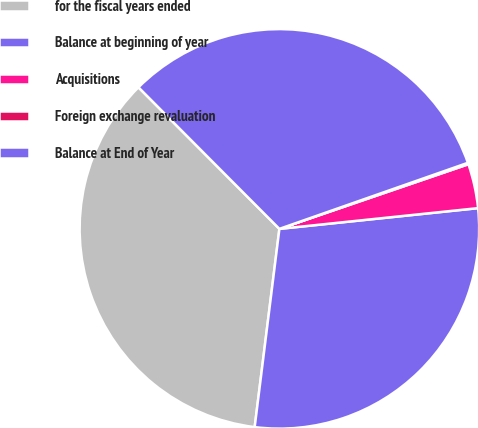<chart> <loc_0><loc_0><loc_500><loc_500><pie_chart><fcel>for the fiscal years ended<fcel>Balance at beginning of year<fcel>Acquisitions<fcel>Foreign exchange revaluation<fcel>Balance at End of Year<nl><fcel>35.56%<fcel>28.63%<fcel>3.59%<fcel>0.12%<fcel>32.1%<nl></chart> 